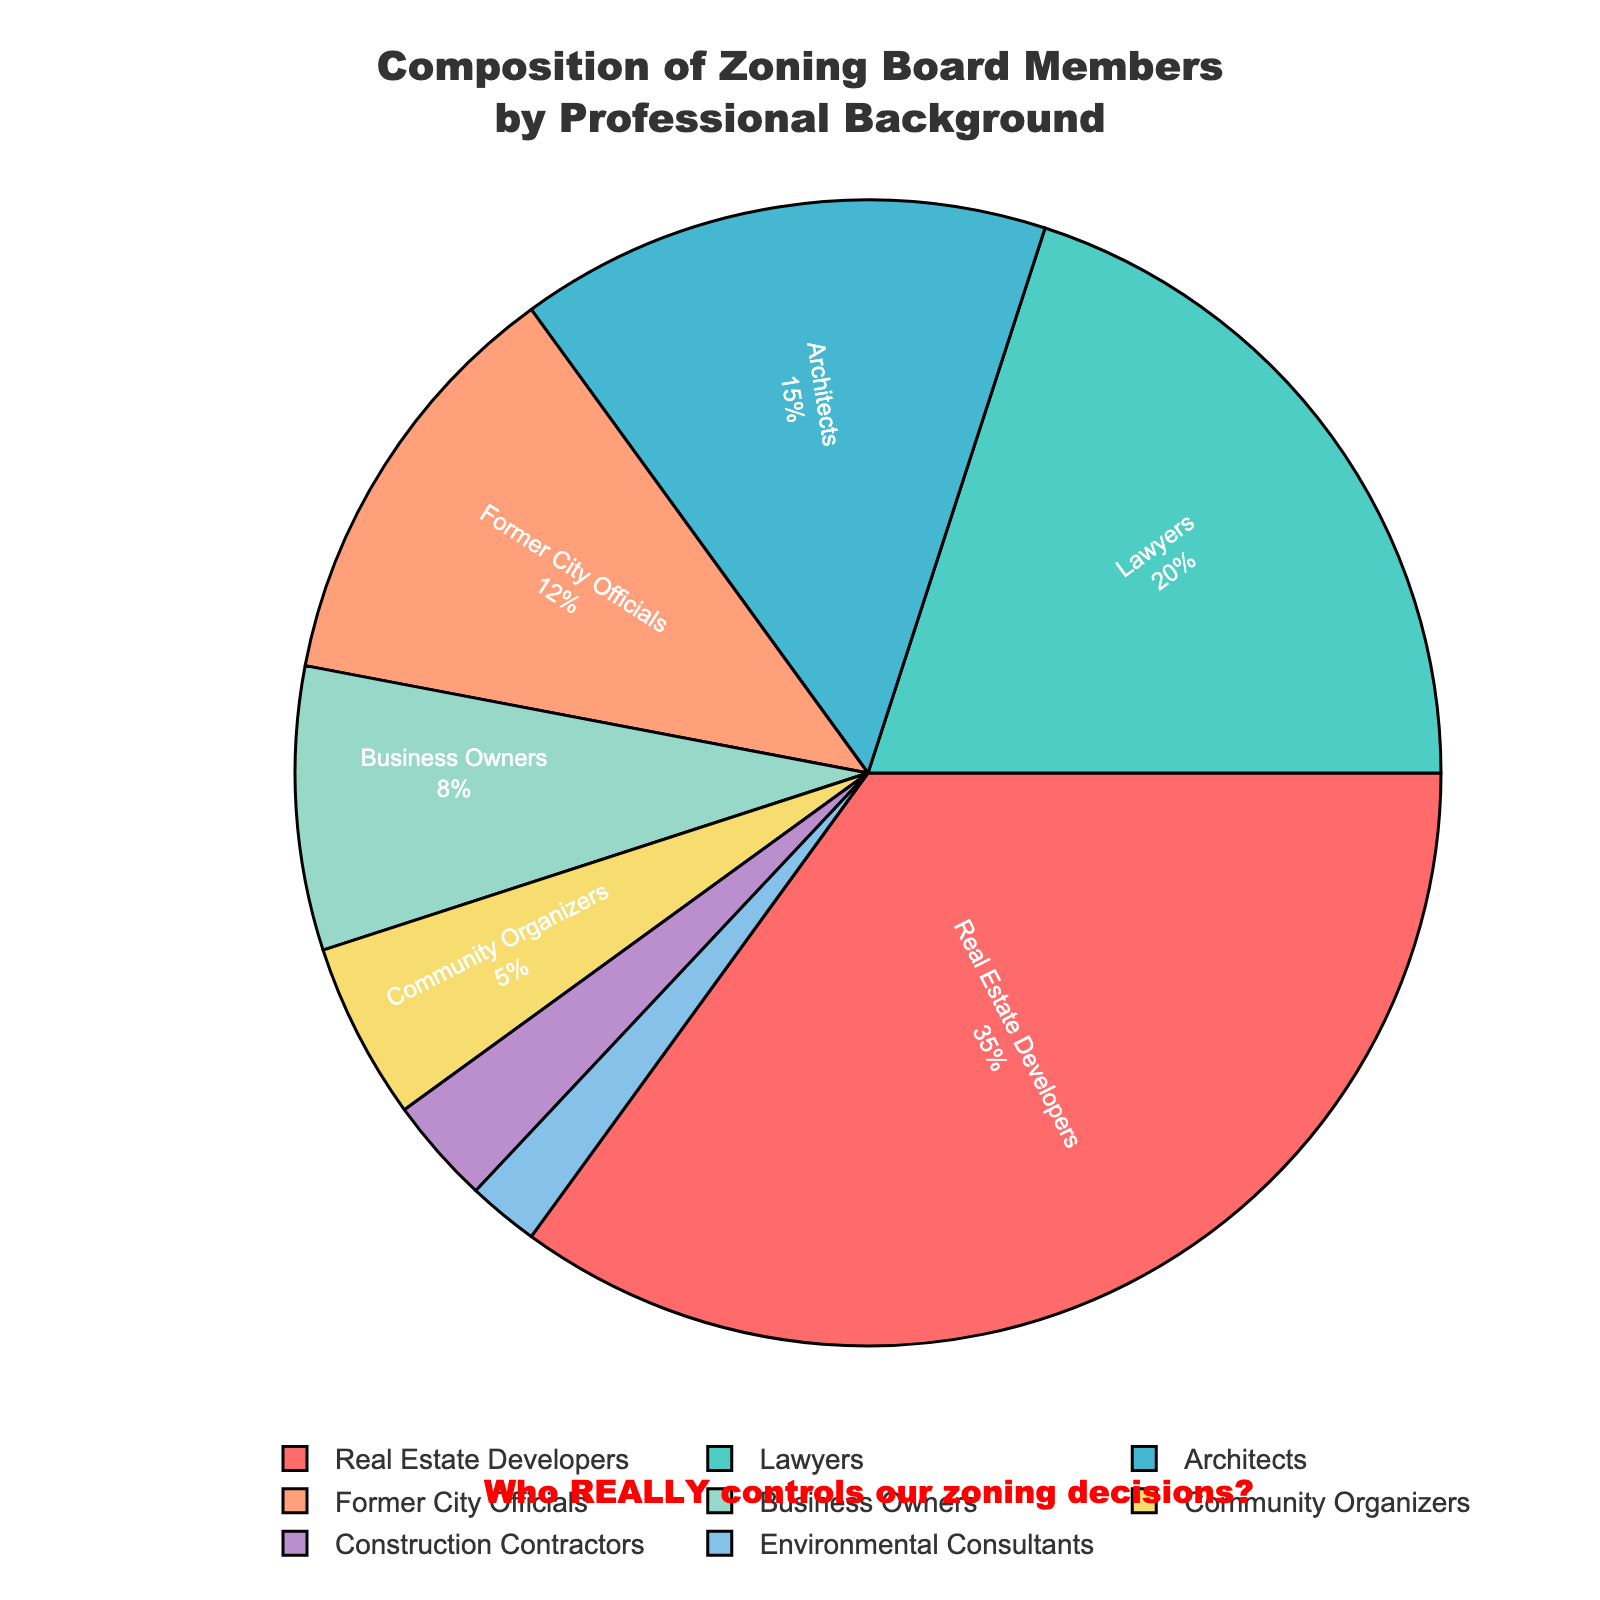what is the combined percentage of zoning board members who are either real estate developers or lawyers? To find the combined percentage, we simply add the percentages of real estate developers (35%) and lawyers (20%): 35% + 20% = 55%.
Answer: 55% which professional background has the lowest representation on the zoning board? By checking the provided data, we see that environmental consultants have the lowest percentage at 2%.
Answer: Environmental Consultants how does the percentage of former city officials compare to business owners? The percentage for former city officials is 12% while it is 8% for business owners. Since 12% is greater than 8%, former city officials have a higher representation.
Answer: Former City Officials have a higher representation what visual clue highlights the highest percentage group in the pie chart? The section for the highest percentage group, real estate developers, is the largest slice of the pie chart and is colored red, making it visually prominent.
Answer: Largest slice, colored red how much more significant is the representation of architects compared to community organizers? Architects have a representation of 15%, while community organizers have 5%. The difference is 15% - 5%, which equals 10%.
Answer: 10% what’s the average representation percentage across all professional backgrounds? To find the average percentage, add up all the percentages (35 + 20 + 15 + 12 + 8 + 5 + 3 + 2 = 100) and divide by the number of backgrounds (8): 100 / 8 = 12.5%.
Answer: 12.5% if zoning decisions favor the majority’s influence, which professional background likely holds the most sway? The largest group's influence is real estate developers, as they represent 35% of the zoning board.
Answer: Real Estate Developers what's the combined representation percentage of environmental consultants, community organizers, and construction contractors? Adding the percentages: 2% (Environmental Consultants) + 5% (Community Organizers) + 3% (Construction Contractors) = 10%.
Answer: 10% which groups together constitute less than 10% of the zoning board? Both construction contractors (3%) and environmental consultants (2%) together constitute 5%, which is less than 10%.
Answer: Construction Contractors and Environmental Consultants 